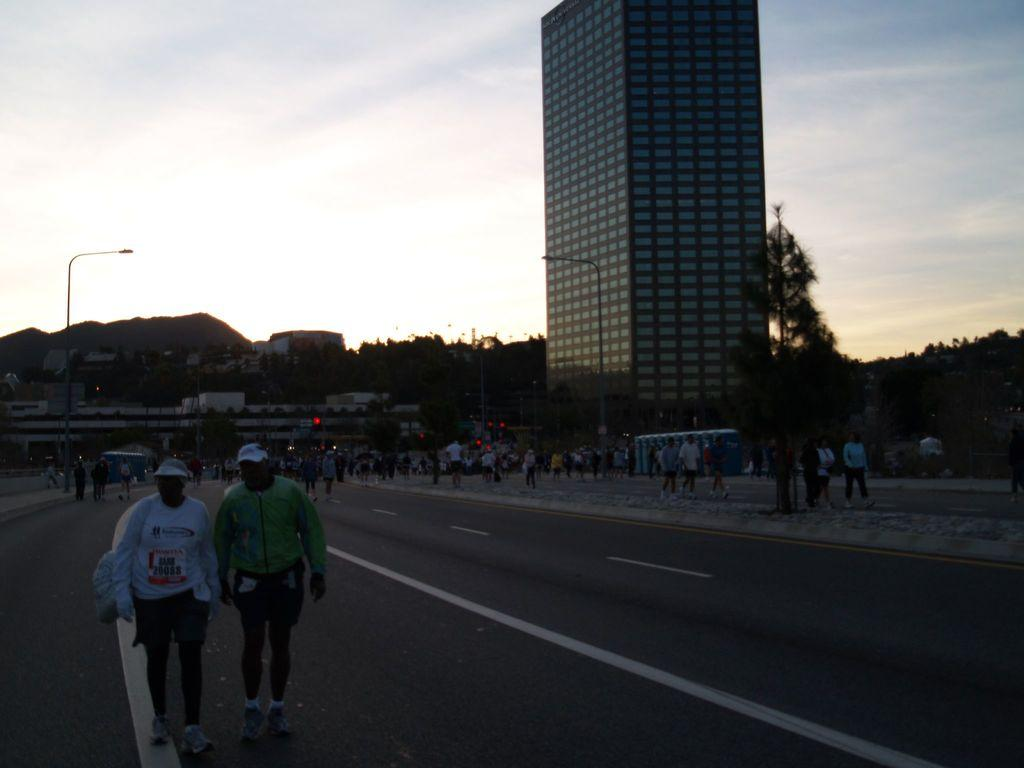What are the people in the image doing? There is a group of people walking on the road in the image. What can be seen in the distance behind the people? There are buildings, trees, street lights, and mountains in the background. What type of music is being played by the quill in the image? There is no quill or music present in the image; it features a group of people walking on the road with a background of buildings, trees, street lights, and mountains. 